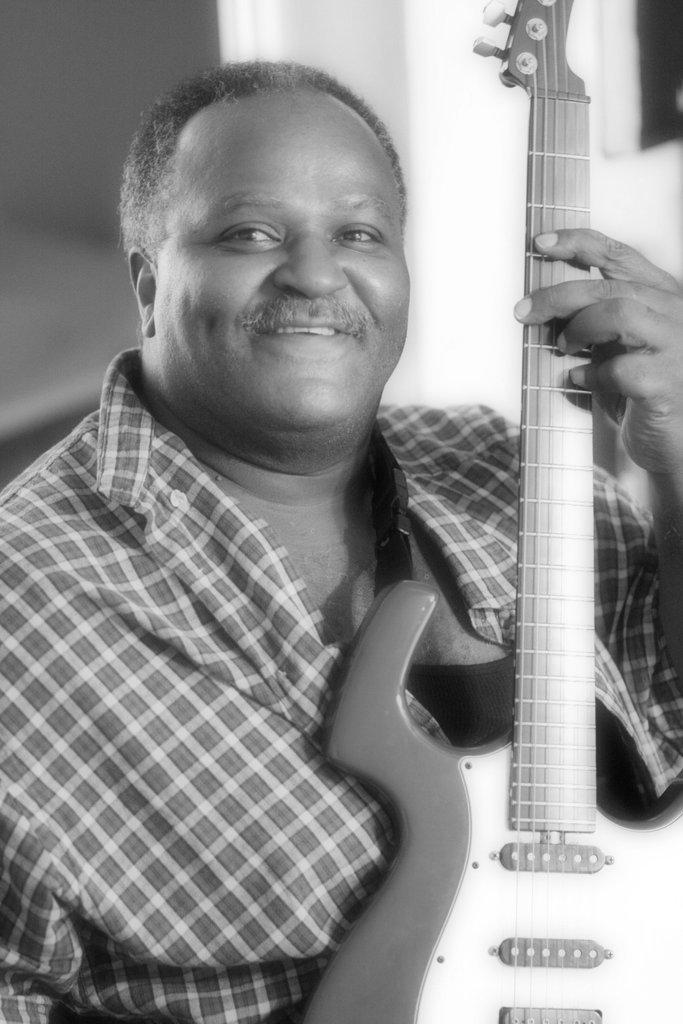What is the color scheme of the image? The image is black and white. Who is present in the image? There is a man in the image. What is the man wearing? The man is wearing a shirt. What expression does the man have? The man is smiling. What object is the man holding? The man is holding a guitar. What type of ball is the man playing with in the image? There is no ball present in the image; the man is holding a guitar. 